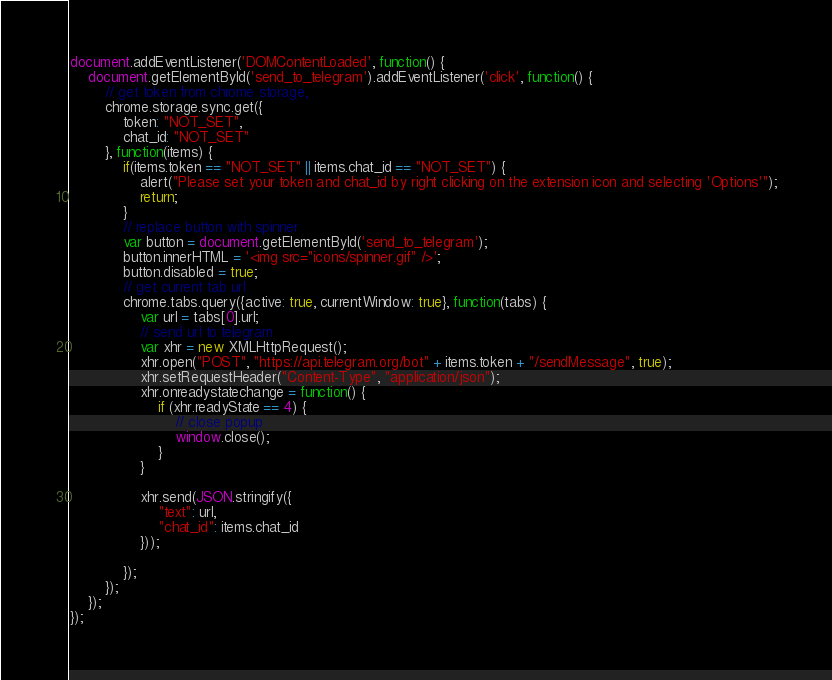<code> <loc_0><loc_0><loc_500><loc_500><_JavaScript_>document.addEventListener('DOMContentLoaded', function() {
    document.getElementById('send_to_telegram').addEventListener('click', function() {    
        // get token from chrome storage, 
        chrome.storage.sync.get({
            token: "NOT_SET",
            chat_id: "NOT_SET"
        }, function(items) {
            if(items.token == "NOT_SET" || items.chat_id == "NOT_SET") {
                alert("Please set your token and chat_id by right clicking on the extension icon and selecting 'Options'");
                return;
            }
            // replace button with spinner
            var button = document.getElementById('send_to_telegram');
            button.innerHTML = '<img src="icons/spinner.gif" />';
            button.disabled = true;
            // get current tab url
            chrome.tabs.query({active: true, currentWindow: true}, function(tabs) {
                var url = tabs[0].url;
                // send url to telegram
                var xhr = new XMLHttpRequest();
                xhr.open("POST", "https://api.telegram.org/bot" + items.token + "/sendMessage", true);
                xhr.setRequestHeader("Content-Type", "application/json");
                xhr.onreadystatechange = function() {
                    if (xhr.readyState == 4) {
                        // close popup
                        window.close();
                    }
                }

                xhr.send(JSON.stringify({
                    "text": url,
                    "chat_id": items.chat_id
                }));
                
            });
        });
    });
});

</code> 